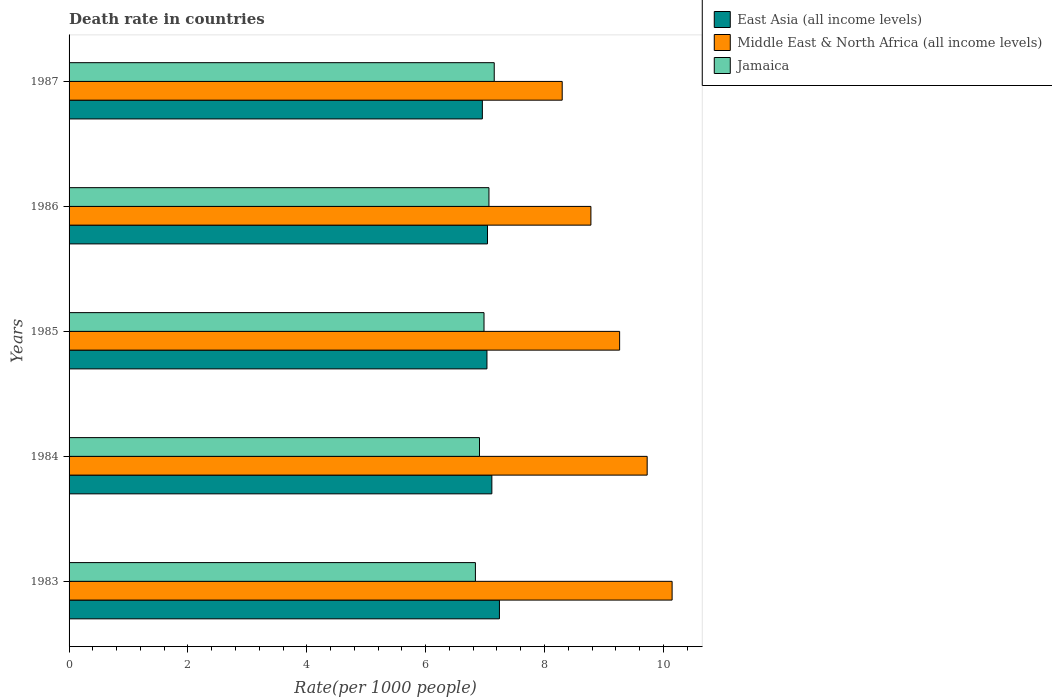How many different coloured bars are there?
Give a very brief answer. 3. Are the number of bars per tick equal to the number of legend labels?
Provide a short and direct response. Yes. How many bars are there on the 3rd tick from the top?
Provide a short and direct response. 3. What is the label of the 5th group of bars from the top?
Offer a very short reply. 1983. What is the death rate in Jamaica in 1984?
Offer a terse response. 6.91. Across all years, what is the maximum death rate in Jamaica?
Your answer should be compact. 7.15. Across all years, what is the minimum death rate in Jamaica?
Your response must be concise. 6.84. In which year was the death rate in East Asia (all income levels) maximum?
Keep it short and to the point. 1983. In which year was the death rate in Middle East & North Africa (all income levels) minimum?
Give a very brief answer. 1987. What is the total death rate in East Asia (all income levels) in the graph?
Offer a very short reply. 35.38. What is the difference between the death rate in Jamaica in 1986 and that in 1987?
Your answer should be very brief. -0.09. What is the difference between the death rate in Jamaica in 1987 and the death rate in Middle East & North Africa (all income levels) in 1984?
Provide a short and direct response. -2.57. What is the average death rate in Middle East & North Africa (all income levels) per year?
Offer a terse response. 9.24. In the year 1985, what is the difference between the death rate in Middle East & North Africa (all income levels) and death rate in Jamaica?
Ensure brevity in your answer.  2.28. In how many years, is the death rate in Jamaica greater than 6.4 ?
Offer a terse response. 5. What is the ratio of the death rate in Middle East & North Africa (all income levels) in 1984 to that in 1987?
Your answer should be compact. 1.17. Is the death rate in Middle East & North Africa (all income levels) in 1983 less than that in 1984?
Your answer should be very brief. No. Is the difference between the death rate in Middle East & North Africa (all income levels) in 1984 and 1987 greater than the difference between the death rate in Jamaica in 1984 and 1987?
Ensure brevity in your answer.  Yes. What is the difference between the highest and the second highest death rate in East Asia (all income levels)?
Provide a succinct answer. 0.13. What is the difference between the highest and the lowest death rate in East Asia (all income levels)?
Provide a short and direct response. 0.29. Is the sum of the death rate in East Asia (all income levels) in 1984 and 1987 greater than the maximum death rate in Middle East & North Africa (all income levels) across all years?
Provide a short and direct response. Yes. What does the 2nd bar from the top in 1986 represents?
Keep it short and to the point. Middle East & North Africa (all income levels). What does the 3rd bar from the bottom in 1987 represents?
Provide a short and direct response. Jamaica. How many years are there in the graph?
Your answer should be very brief. 5. Are the values on the major ticks of X-axis written in scientific E-notation?
Make the answer very short. No. How many legend labels are there?
Give a very brief answer. 3. What is the title of the graph?
Give a very brief answer. Death rate in countries. Does "Grenada" appear as one of the legend labels in the graph?
Give a very brief answer. No. What is the label or title of the X-axis?
Ensure brevity in your answer.  Rate(per 1000 people). What is the Rate(per 1000 people) of East Asia (all income levels) in 1983?
Your answer should be compact. 7.24. What is the Rate(per 1000 people) in Middle East & North Africa (all income levels) in 1983?
Provide a short and direct response. 10.15. What is the Rate(per 1000 people) in Jamaica in 1983?
Offer a terse response. 6.84. What is the Rate(per 1000 people) in East Asia (all income levels) in 1984?
Offer a terse response. 7.11. What is the Rate(per 1000 people) in Middle East & North Africa (all income levels) in 1984?
Your answer should be very brief. 9.73. What is the Rate(per 1000 people) of Jamaica in 1984?
Your answer should be compact. 6.91. What is the Rate(per 1000 people) in East Asia (all income levels) in 1985?
Provide a succinct answer. 7.03. What is the Rate(per 1000 people) in Middle East & North Africa (all income levels) in 1985?
Your response must be concise. 9.26. What is the Rate(per 1000 people) in Jamaica in 1985?
Keep it short and to the point. 6.98. What is the Rate(per 1000 people) in East Asia (all income levels) in 1986?
Offer a very short reply. 7.04. What is the Rate(per 1000 people) of Middle East & North Africa (all income levels) in 1986?
Offer a terse response. 8.78. What is the Rate(per 1000 people) in Jamaica in 1986?
Your answer should be compact. 7.07. What is the Rate(per 1000 people) of East Asia (all income levels) in 1987?
Your answer should be compact. 6.95. What is the Rate(per 1000 people) in Middle East & North Africa (all income levels) in 1987?
Give a very brief answer. 8.3. What is the Rate(per 1000 people) in Jamaica in 1987?
Your answer should be compact. 7.15. Across all years, what is the maximum Rate(per 1000 people) in East Asia (all income levels)?
Provide a short and direct response. 7.24. Across all years, what is the maximum Rate(per 1000 people) in Middle East & North Africa (all income levels)?
Offer a terse response. 10.15. Across all years, what is the maximum Rate(per 1000 people) of Jamaica?
Provide a short and direct response. 7.15. Across all years, what is the minimum Rate(per 1000 people) of East Asia (all income levels)?
Your answer should be compact. 6.95. Across all years, what is the minimum Rate(per 1000 people) of Middle East & North Africa (all income levels)?
Your answer should be compact. 8.3. Across all years, what is the minimum Rate(per 1000 people) of Jamaica?
Your answer should be very brief. 6.84. What is the total Rate(per 1000 people) of East Asia (all income levels) in the graph?
Your response must be concise. 35.38. What is the total Rate(per 1000 people) in Middle East & North Africa (all income levels) in the graph?
Keep it short and to the point. 46.22. What is the total Rate(per 1000 people) of Jamaica in the graph?
Give a very brief answer. 34.94. What is the difference between the Rate(per 1000 people) of East Asia (all income levels) in 1983 and that in 1984?
Offer a terse response. 0.13. What is the difference between the Rate(per 1000 people) in Middle East & North Africa (all income levels) in 1983 and that in 1984?
Your response must be concise. 0.42. What is the difference between the Rate(per 1000 people) of Jamaica in 1983 and that in 1984?
Offer a very short reply. -0.07. What is the difference between the Rate(per 1000 people) in East Asia (all income levels) in 1983 and that in 1985?
Provide a short and direct response. 0.21. What is the difference between the Rate(per 1000 people) of Middle East & North Africa (all income levels) in 1983 and that in 1985?
Your answer should be compact. 0.88. What is the difference between the Rate(per 1000 people) of Jamaica in 1983 and that in 1985?
Provide a succinct answer. -0.14. What is the difference between the Rate(per 1000 people) of East Asia (all income levels) in 1983 and that in 1986?
Your answer should be very brief. 0.2. What is the difference between the Rate(per 1000 people) of Middle East & North Africa (all income levels) in 1983 and that in 1986?
Keep it short and to the point. 1.37. What is the difference between the Rate(per 1000 people) of Jamaica in 1983 and that in 1986?
Make the answer very short. -0.23. What is the difference between the Rate(per 1000 people) in East Asia (all income levels) in 1983 and that in 1987?
Ensure brevity in your answer.  0.29. What is the difference between the Rate(per 1000 people) in Middle East & North Africa (all income levels) in 1983 and that in 1987?
Your answer should be compact. 1.85. What is the difference between the Rate(per 1000 people) in Jamaica in 1983 and that in 1987?
Provide a short and direct response. -0.32. What is the difference between the Rate(per 1000 people) in East Asia (all income levels) in 1984 and that in 1985?
Keep it short and to the point. 0.08. What is the difference between the Rate(per 1000 people) of Middle East & North Africa (all income levels) in 1984 and that in 1985?
Your answer should be very brief. 0.46. What is the difference between the Rate(per 1000 people) in Jamaica in 1984 and that in 1985?
Provide a succinct answer. -0.08. What is the difference between the Rate(per 1000 people) in East Asia (all income levels) in 1984 and that in 1986?
Provide a succinct answer. 0.07. What is the difference between the Rate(per 1000 people) in Middle East & North Africa (all income levels) in 1984 and that in 1986?
Ensure brevity in your answer.  0.95. What is the difference between the Rate(per 1000 people) of Jamaica in 1984 and that in 1986?
Offer a terse response. -0.16. What is the difference between the Rate(per 1000 people) in East Asia (all income levels) in 1984 and that in 1987?
Ensure brevity in your answer.  0.16. What is the difference between the Rate(per 1000 people) in Middle East & North Africa (all income levels) in 1984 and that in 1987?
Your response must be concise. 1.43. What is the difference between the Rate(per 1000 people) in Jamaica in 1984 and that in 1987?
Offer a terse response. -0.25. What is the difference between the Rate(per 1000 people) in East Asia (all income levels) in 1985 and that in 1986?
Keep it short and to the point. -0.01. What is the difference between the Rate(per 1000 people) of Middle East & North Africa (all income levels) in 1985 and that in 1986?
Keep it short and to the point. 0.48. What is the difference between the Rate(per 1000 people) in Jamaica in 1985 and that in 1986?
Your answer should be very brief. -0.08. What is the difference between the Rate(per 1000 people) of East Asia (all income levels) in 1985 and that in 1987?
Keep it short and to the point. 0.08. What is the difference between the Rate(per 1000 people) of Middle East & North Africa (all income levels) in 1985 and that in 1987?
Offer a very short reply. 0.97. What is the difference between the Rate(per 1000 people) in Jamaica in 1985 and that in 1987?
Ensure brevity in your answer.  -0.17. What is the difference between the Rate(per 1000 people) of East Asia (all income levels) in 1986 and that in 1987?
Offer a very short reply. 0.09. What is the difference between the Rate(per 1000 people) in Middle East & North Africa (all income levels) in 1986 and that in 1987?
Your answer should be very brief. 0.48. What is the difference between the Rate(per 1000 people) in Jamaica in 1986 and that in 1987?
Offer a terse response. -0.09. What is the difference between the Rate(per 1000 people) of East Asia (all income levels) in 1983 and the Rate(per 1000 people) of Middle East & North Africa (all income levels) in 1984?
Make the answer very short. -2.49. What is the difference between the Rate(per 1000 people) of East Asia (all income levels) in 1983 and the Rate(per 1000 people) of Jamaica in 1984?
Give a very brief answer. 0.34. What is the difference between the Rate(per 1000 people) in Middle East & North Africa (all income levels) in 1983 and the Rate(per 1000 people) in Jamaica in 1984?
Provide a short and direct response. 3.24. What is the difference between the Rate(per 1000 people) of East Asia (all income levels) in 1983 and the Rate(per 1000 people) of Middle East & North Africa (all income levels) in 1985?
Your response must be concise. -2.02. What is the difference between the Rate(per 1000 people) of East Asia (all income levels) in 1983 and the Rate(per 1000 people) of Jamaica in 1985?
Offer a very short reply. 0.26. What is the difference between the Rate(per 1000 people) of Middle East & North Africa (all income levels) in 1983 and the Rate(per 1000 people) of Jamaica in 1985?
Your answer should be compact. 3.16. What is the difference between the Rate(per 1000 people) of East Asia (all income levels) in 1983 and the Rate(per 1000 people) of Middle East & North Africa (all income levels) in 1986?
Provide a short and direct response. -1.54. What is the difference between the Rate(per 1000 people) of East Asia (all income levels) in 1983 and the Rate(per 1000 people) of Jamaica in 1986?
Your answer should be compact. 0.18. What is the difference between the Rate(per 1000 people) of Middle East & North Africa (all income levels) in 1983 and the Rate(per 1000 people) of Jamaica in 1986?
Your answer should be compact. 3.08. What is the difference between the Rate(per 1000 people) in East Asia (all income levels) in 1983 and the Rate(per 1000 people) in Middle East & North Africa (all income levels) in 1987?
Offer a terse response. -1.06. What is the difference between the Rate(per 1000 people) in East Asia (all income levels) in 1983 and the Rate(per 1000 people) in Jamaica in 1987?
Offer a terse response. 0.09. What is the difference between the Rate(per 1000 people) in Middle East & North Africa (all income levels) in 1983 and the Rate(per 1000 people) in Jamaica in 1987?
Keep it short and to the point. 2.99. What is the difference between the Rate(per 1000 people) in East Asia (all income levels) in 1984 and the Rate(per 1000 people) in Middle East & North Africa (all income levels) in 1985?
Provide a short and direct response. -2.15. What is the difference between the Rate(per 1000 people) in East Asia (all income levels) in 1984 and the Rate(per 1000 people) in Jamaica in 1985?
Give a very brief answer. 0.13. What is the difference between the Rate(per 1000 people) in Middle East & North Africa (all income levels) in 1984 and the Rate(per 1000 people) in Jamaica in 1985?
Keep it short and to the point. 2.75. What is the difference between the Rate(per 1000 people) in East Asia (all income levels) in 1984 and the Rate(per 1000 people) in Middle East & North Africa (all income levels) in 1986?
Ensure brevity in your answer.  -1.67. What is the difference between the Rate(per 1000 people) in East Asia (all income levels) in 1984 and the Rate(per 1000 people) in Jamaica in 1986?
Ensure brevity in your answer.  0.05. What is the difference between the Rate(per 1000 people) in Middle East & North Africa (all income levels) in 1984 and the Rate(per 1000 people) in Jamaica in 1986?
Provide a short and direct response. 2.66. What is the difference between the Rate(per 1000 people) in East Asia (all income levels) in 1984 and the Rate(per 1000 people) in Middle East & North Africa (all income levels) in 1987?
Your answer should be very brief. -1.18. What is the difference between the Rate(per 1000 people) of East Asia (all income levels) in 1984 and the Rate(per 1000 people) of Jamaica in 1987?
Your response must be concise. -0.04. What is the difference between the Rate(per 1000 people) in Middle East & North Africa (all income levels) in 1984 and the Rate(per 1000 people) in Jamaica in 1987?
Keep it short and to the point. 2.57. What is the difference between the Rate(per 1000 people) of East Asia (all income levels) in 1985 and the Rate(per 1000 people) of Middle East & North Africa (all income levels) in 1986?
Ensure brevity in your answer.  -1.75. What is the difference between the Rate(per 1000 people) of East Asia (all income levels) in 1985 and the Rate(per 1000 people) of Jamaica in 1986?
Provide a succinct answer. -0.03. What is the difference between the Rate(per 1000 people) of Middle East & North Africa (all income levels) in 1985 and the Rate(per 1000 people) of Jamaica in 1986?
Provide a short and direct response. 2.2. What is the difference between the Rate(per 1000 people) in East Asia (all income levels) in 1985 and the Rate(per 1000 people) in Middle East & North Africa (all income levels) in 1987?
Provide a short and direct response. -1.27. What is the difference between the Rate(per 1000 people) in East Asia (all income levels) in 1985 and the Rate(per 1000 people) in Jamaica in 1987?
Ensure brevity in your answer.  -0.12. What is the difference between the Rate(per 1000 people) in Middle East & North Africa (all income levels) in 1985 and the Rate(per 1000 people) in Jamaica in 1987?
Your answer should be very brief. 2.11. What is the difference between the Rate(per 1000 people) of East Asia (all income levels) in 1986 and the Rate(per 1000 people) of Middle East & North Africa (all income levels) in 1987?
Make the answer very short. -1.26. What is the difference between the Rate(per 1000 people) in East Asia (all income levels) in 1986 and the Rate(per 1000 people) in Jamaica in 1987?
Ensure brevity in your answer.  -0.11. What is the difference between the Rate(per 1000 people) of Middle East & North Africa (all income levels) in 1986 and the Rate(per 1000 people) of Jamaica in 1987?
Ensure brevity in your answer.  1.63. What is the average Rate(per 1000 people) of East Asia (all income levels) per year?
Your response must be concise. 7.08. What is the average Rate(per 1000 people) of Middle East & North Africa (all income levels) per year?
Give a very brief answer. 9.24. What is the average Rate(per 1000 people) in Jamaica per year?
Provide a short and direct response. 6.99. In the year 1983, what is the difference between the Rate(per 1000 people) of East Asia (all income levels) and Rate(per 1000 people) of Middle East & North Africa (all income levels)?
Your answer should be very brief. -2.91. In the year 1983, what is the difference between the Rate(per 1000 people) of East Asia (all income levels) and Rate(per 1000 people) of Jamaica?
Offer a terse response. 0.4. In the year 1983, what is the difference between the Rate(per 1000 people) of Middle East & North Africa (all income levels) and Rate(per 1000 people) of Jamaica?
Offer a terse response. 3.31. In the year 1984, what is the difference between the Rate(per 1000 people) of East Asia (all income levels) and Rate(per 1000 people) of Middle East & North Africa (all income levels)?
Provide a short and direct response. -2.61. In the year 1984, what is the difference between the Rate(per 1000 people) of East Asia (all income levels) and Rate(per 1000 people) of Jamaica?
Provide a short and direct response. 0.21. In the year 1984, what is the difference between the Rate(per 1000 people) in Middle East & North Africa (all income levels) and Rate(per 1000 people) in Jamaica?
Make the answer very short. 2.82. In the year 1985, what is the difference between the Rate(per 1000 people) of East Asia (all income levels) and Rate(per 1000 people) of Middle East & North Africa (all income levels)?
Your response must be concise. -2.23. In the year 1985, what is the difference between the Rate(per 1000 people) in East Asia (all income levels) and Rate(per 1000 people) in Jamaica?
Give a very brief answer. 0.05. In the year 1985, what is the difference between the Rate(per 1000 people) of Middle East & North Africa (all income levels) and Rate(per 1000 people) of Jamaica?
Your response must be concise. 2.28. In the year 1986, what is the difference between the Rate(per 1000 people) in East Asia (all income levels) and Rate(per 1000 people) in Middle East & North Africa (all income levels)?
Offer a terse response. -1.74. In the year 1986, what is the difference between the Rate(per 1000 people) in East Asia (all income levels) and Rate(per 1000 people) in Jamaica?
Your response must be concise. -0.02. In the year 1986, what is the difference between the Rate(per 1000 people) in Middle East & North Africa (all income levels) and Rate(per 1000 people) in Jamaica?
Provide a short and direct response. 1.72. In the year 1987, what is the difference between the Rate(per 1000 people) in East Asia (all income levels) and Rate(per 1000 people) in Middle East & North Africa (all income levels)?
Ensure brevity in your answer.  -1.34. In the year 1987, what is the difference between the Rate(per 1000 people) of Middle East & North Africa (all income levels) and Rate(per 1000 people) of Jamaica?
Provide a short and direct response. 1.14. What is the ratio of the Rate(per 1000 people) of East Asia (all income levels) in 1983 to that in 1984?
Your answer should be compact. 1.02. What is the ratio of the Rate(per 1000 people) of Middle East & North Africa (all income levels) in 1983 to that in 1984?
Your answer should be compact. 1.04. What is the ratio of the Rate(per 1000 people) in Jamaica in 1983 to that in 1984?
Offer a terse response. 0.99. What is the ratio of the Rate(per 1000 people) of East Asia (all income levels) in 1983 to that in 1985?
Provide a succinct answer. 1.03. What is the ratio of the Rate(per 1000 people) in Middle East & North Africa (all income levels) in 1983 to that in 1985?
Your response must be concise. 1.1. What is the ratio of the Rate(per 1000 people) of Jamaica in 1983 to that in 1985?
Your answer should be compact. 0.98. What is the ratio of the Rate(per 1000 people) of East Asia (all income levels) in 1983 to that in 1986?
Ensure brevity in your answer.  1.03. What is the ratio of the Rate(per 1000 people) of Middle East & North Africa (all income levels) in 1983 to that in 1986?
Provide a succinct answer. 1.16. What is the ratio of the Rate(per 1000 people) in Jamaica in 1983 to that in 1986?
Offer a very short reply. 0.97. What is the ratio of the Rate(per 1000 people) of East Asia (all income levels) in 1983 to that in 1987?
Your answer should be very brief. 1.04. What is the ratio of the Rate(per 1000 people) of Middle East & North Africa (all income levels) in 1983 to that in 1987?
Keep it short and to the point. 1.22. What is the ratio of the Rate(per 1000 people) in Jamaica in 1983 to that in 1987?
Ensure brevity in your answer.  0.96. What is the ratio of the Rate(per 1000 people) in East Asia (all income levels) in 1984 to that in 1985?
Provide a short and direct response. 1.01. What is the ratio of the Rate(per 1000 people) in Middle East & North Africa (all income levels) in 1984 to that in 1985?
Provide a short and direct response. 1.05. What is the ratio of the Rate(per 1000 people) in Jamaica in 1984 to that in 1985?
Give a very brief answer. 0.99. What is the ratio of the Rate(per 1000 people) of East Asia (all income levels) in 1984 to that in 1986?
Keep it short and to the point. 1.01. What is the ratio of the Rate(per 1000 people) in Middle East & North Africa (all income levels) in 1984 to that in 1986?
Your response must be concise. 1.11. What is the ratio of the Rate(per 1000 people) in Jamaica in 1984 to that in 1986?
Your answer should be compact. 0.98. What is the ratio of the Rate(per 1000 people) in Middle East & North Africa (all income levels) in 1984 to that in 1987?
Offer a terse response. 1.17. What is the ratio of the Rate(per 1000 people) of Jamaica in 1984 to that in 1987?
Offer a terse response. 0.97. What is the ratio of the Rate(per 1000 people) in Middle East & North Africa (all income levels) in 1985 to that in 1986?
Ensure brevity in your answer.  1.05. What is the ratio of the Rate(per 1000 people) in Jamaica in 1985 to that in 1986?
Keep it short and to the point. 0.99. What is the ratio of the Rate(per 1000 people) in East Asia (all income levels) in 1985 to that in 1987?
Make the answer very short. 1.01. What is the ratio of the Rate(per 1000 people) in Middle East & North Africa (all income levels) in 1985 to that in 1987?
Your answer should be very brief. 1.12. What is the ratio of the Rate(per 1000 people) in Jamaica in 1985 to that in 1987?
Give a very brief answer. 0.98. What is the ratio of the Rate(per 1000 people) in East Asia (all income levels) in 1986 to that in 1987?
Ensure brevity in your answer.  1.01. What is the ratio of the Rate(per 1000 people) of Middle East & North Africa (all income levels) in 1986 to that in 1987?
Make the answer very short. 1.06. What is the ratio of the Rate(per 1000 people) of Jamaica in 1986 to that in 1987?
Your answer should be very brief. 0.99. What is the difference between the highest and the second highest Rate(per 1000 people) of East Asia (all income levels)?
Your answer should be compact. 0.13. What is the difference between the highest and the second highest Rate(per 1000 people) in Middle East & North Africa (all income levels)?
Your answer should be compact. 0.42. What is the difference between the highest and the second highest Rate(per 1000 people) of Jamaica?
Make the answer very short. 0.09. What is the difference between the highest and the lowest Rate(per 1000 people) of East Asia (all income levels)?
Give a very brief answer. 0.29. What is the difference between the highest and the lowest Rate(per 1000 people) of Middle East & North Africa (all income levels)?
Your response must be concise. 1.85. What is the difference between the highest and the lowest Rate(per 1000 people) in Jamaica?
Your response must be concise. 0.32. 